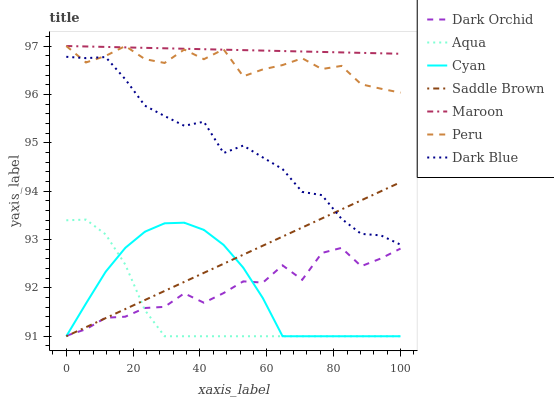Does Aqua have the minimum area under the curve?
Answer yes or no. Yes. Does Maroon have the maximum area under the curve?
Answer yes or no. Yes. Does Dark Blue have the minimum area under the curve?
Answer yes or no. No. Does Dark Blue have the maximum area under the curve?
Answer yes or no. No. Is Maroon the smoothest?
Answer yes or no. Yes. Is Dark Orchid the roughest?
Answer yes or no. Yes. Is Dark Blue the smoothest?
Answer yes or no. No. Is Dark Blue the roughest?
Answer yes or no. No. Does Aqua have the lowest value?
Answer yes or no. Yes. Does Dark Blue have the lowest value?
Answer yes or no. No. Does Peru have the highest value?
Answer yes or no. Yes. Does Dark Blue have the highest value?
Answer yes or no. No. Is Saddle Brown less than Peru?
Answer yes or no. Yes. Is Dark Blue greater than Cyan?
Answer yes or no. Yes. Does Peru intersect Dark Blue?
Answer yes or no. Yes. Is Peru less than Dark Blue?
Answer yes or no. No. Is Peru greater than Dark Blue?
Answer yes or no. No. Does Saddle Brown intersect Peru?
Answer yes or no. No. 